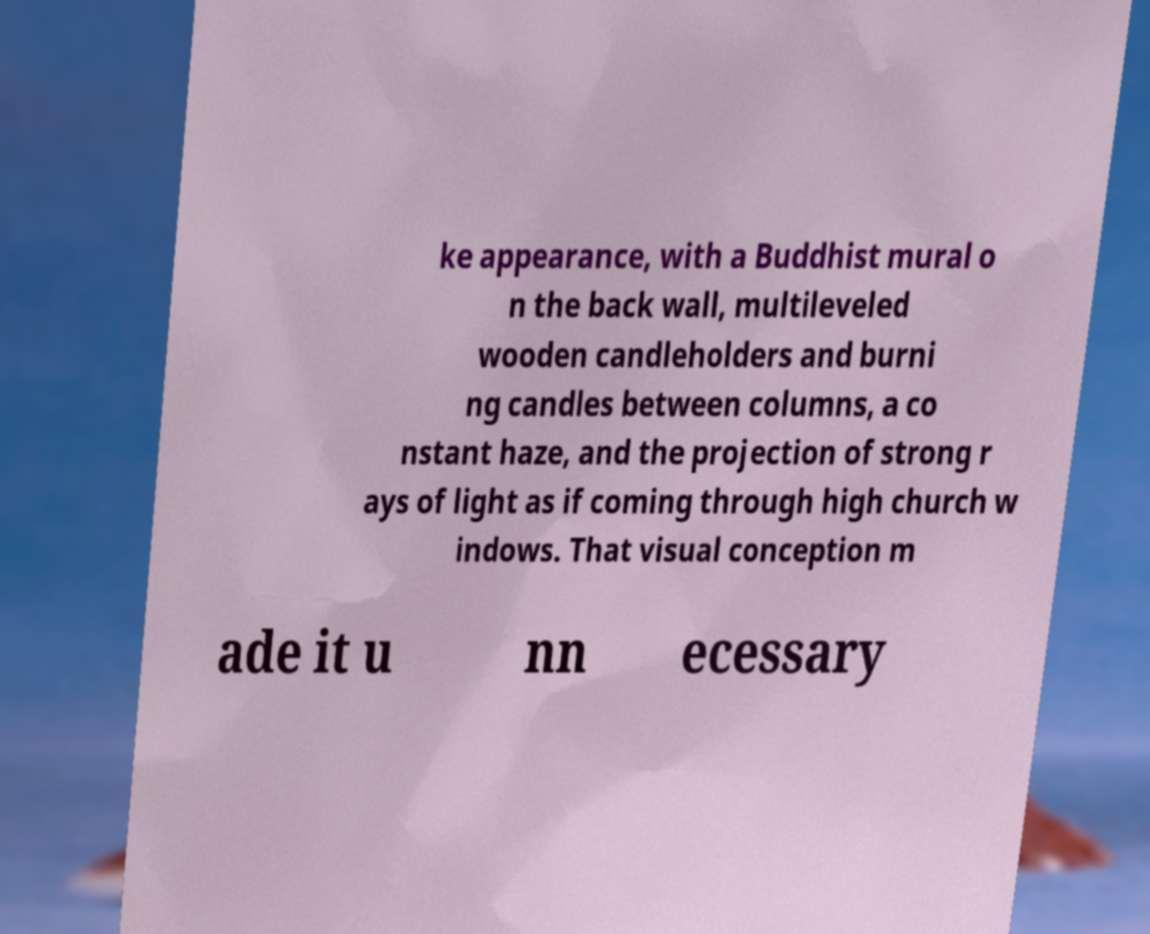Could you extract and type out the text from this image? ke appearance, with a Buddhist mural o n the back wall, multileveled wooden candleholders and burni ng candles between columns, a co nstant haze, and the projection of strong r ays of light as if coming through high church w indows. That visual conception m ade it u nn ecessary 